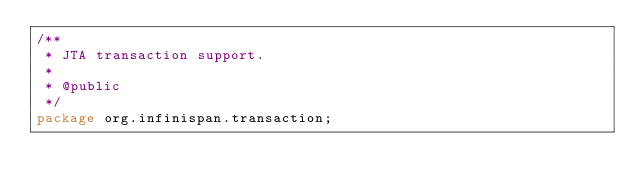Convert code to text. <code><loc_0><loc_0><loc_500><loc_500><_Java_>/**
 * JTA transaction support.
 *
 * @public
 */
package org.infinispan.transaction;
</code> 